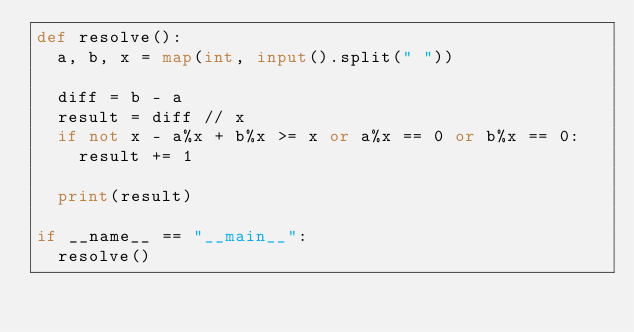<code> <loc_0><loc_0><loc_500><loc_500><_Python_>def resolve():
  a, b, x = map(int, input().split(" "))

  diff = b - a
  result = diff // x
  if not x - a%x + b%x >= x or a%x == 0 or b%x == 0:
    result += 1

  print(result)

if __name__ == "__main__":
  resolve()</code> 